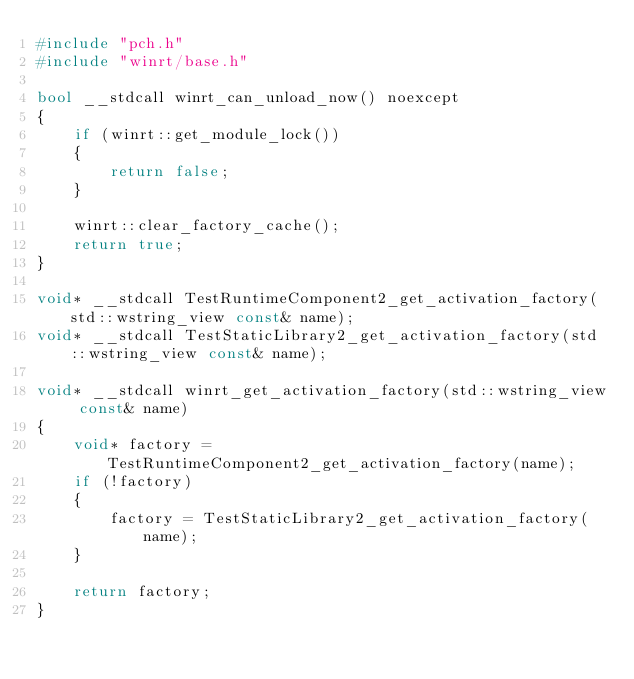<code> <loc_0><loc_0><loc_500><loc_500><_C++_>#include "pch.h"
#include "winrt/base.h"

bool __stdcall winrt_can_unload_now() noexcept
{
    if (winrt::get_module_lock())
    {
        return false;
    }

    winrt::clear_factory_cache();
    return true;
}

void* __stdcall TestRuntimeComponent2_get_activation_factory(std::wstring_view const& name);
void* __stdcall TestStaticLibrary2_get_activation_factory(std::wstring_view const& name);

void* __stdcall winrt_get_activation_factory(std::wstring_view const& name)
{
    void* factory = TestRuntimeComponent2_get_activation_factory(name);
    if (!factory)
    {
        factory = TestStaticLibrary2_get_activation_factory(name);
    }

    return factory;
}
</code> 